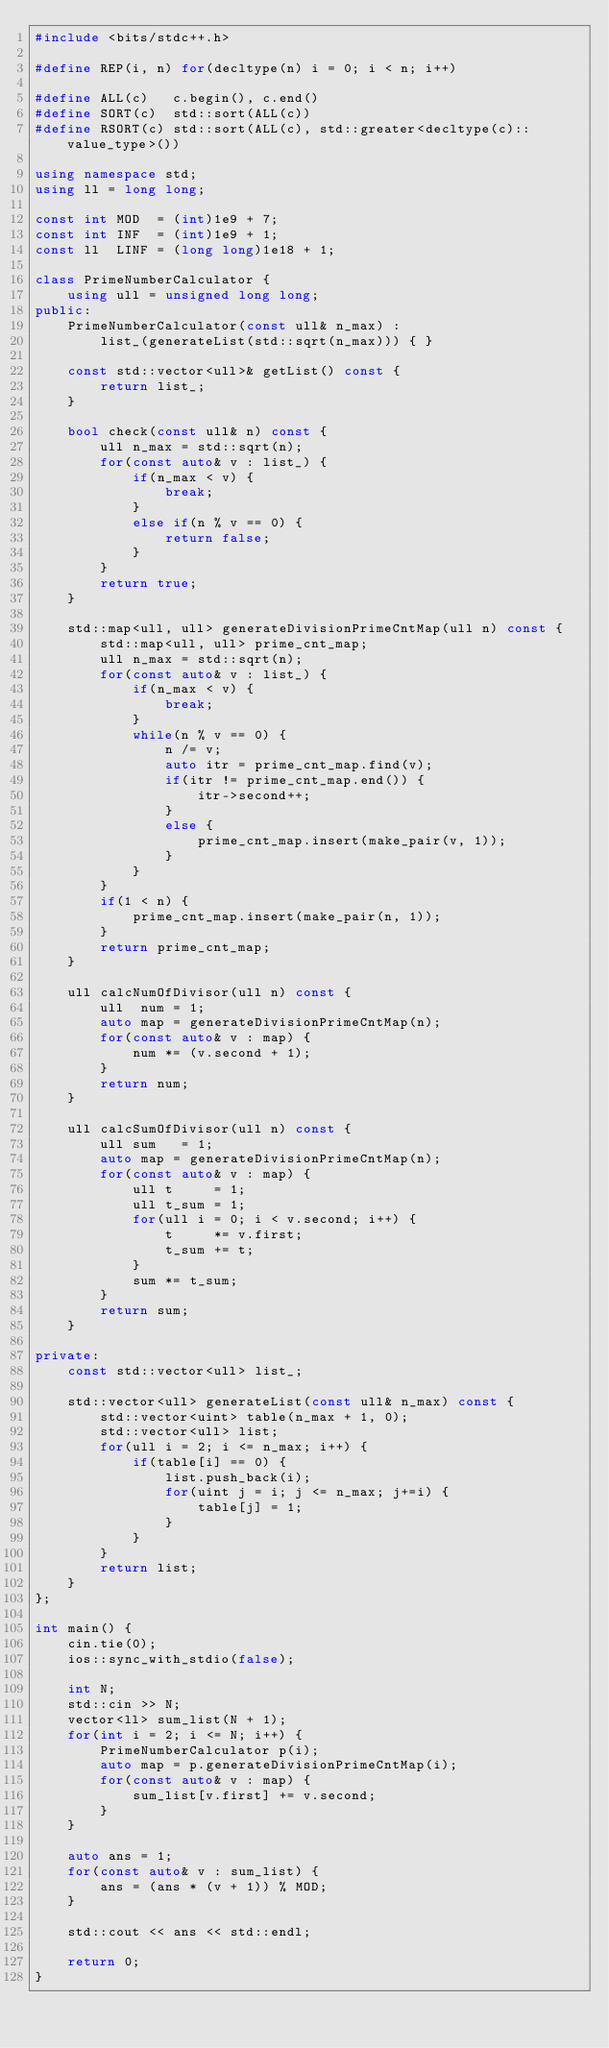<code> <loc_0><loc_0><loc_500><loc_500><_C++_>#include <bits/stdc++.h>

#define REP(i, n) for(decltype(n) i = 0; i < n; i++)

#define ALL(c)   c.begin(), c.end()
#define SORT(c)  std::sort(ALL(c))
#define RSORT(c) std::sort(ALL(c), std::greater<decltype(c)::value_type>())

using namespace std;
using ll = long long;

const int MOD  = (int)1e9 + 7;
const int INF  = (int)1e9 + 1;
const ll  LINF = (long long)1e18 + 1;

class PrimeNumberCalculator {
    using ull = unsigned long long;
public:
    PrimeNumberCalculator(const ull& n_max) :
        list_(generateList(std::sqrt(n_max))) { }

    const std::vector<ull>& getList() const {
        return list_;
    }

    bool check(const ull& n) const {
        ull n_max = std::sqrt(n);
        for(const auto& v : list_) {
            if(n_max < v) {
                break;
            }
            else if(n % v == 0) {
                return false;
            }
        }
        return true;
    }

    std::map<ull, ull> generateDivisionPrimeCntMap(ull n) const {
        std::map<ull, ull> prime_cnt_map;
        ull n_max = std::sqrt(n);
        for(const auto& v : list_) {
            if(n_max < v) {
                break;
            }
            while(n % v == 0) {
                n /= v;
                auto itr = prime_cnt_map.find(v);
                if(itr != prime_cnt_map.end()) {
                    itr->second++;
                }
                else {
                    prime_cnt_map.insert(make_pair(v, 1));
                }
            }
        }
        if(1 < n) {
            prime_cnt_map.insert(make_pair(n, 1));
        }
        return prime_cnt_map;
    }

    ull calcNumOfDivisor(ull n) const {
        ull  num = 1;
        auto map = generateDivisionPrimeCntMap(n);
        for(const auto& v : map) {
            num *= (v.second + 1);
        }
        return num;
    }

    ull calcSumOfDivisor(ull n) const {
        ull sum   = 1;
        auto map = generateDivisionPrimeCntMap(n);
        for(const auto& v : map) {
            ull t     = 1;
            ull t_sum = 1;
            for(ull i = 0; i < v.second; i++) {
                t     *= v.first;
                t_sum += t;
            }
            sum *= t_sum;
        }
        return sum;
    }

private:
    const std::vector<ull> list_;

    std::vector<ull> generateList(const ull& n_max) const {
        std::vector<uint> table(n_max + 1, 0);
        std::vector<ull> list;
        for(ull i = 2; i <= n_max; i++) {
            if(table[i] == 0) {
                list.push_back(i);
                for(uint j = i; j <= n_max; j+=i) {
                    table[j] = 1;
                }
            }
        }
        return list;
    }
};

int main() {
    cin.tie(0);
    ios::sync_with_stdio(false);

    int N;
    std::cin >> N;
    vector<ll> sum_list(N + 1);
    for(int i = 2; i <= N; i++) {
        PrimeNumberCalculator p(i);
        auto map = p.generateDivisionPrimeCntMap(i);
        for(const auto& v : map) {
            sum_list[v.first] += v.second;
        }
    }

    auto ans = 1;
    for(const auto& v : sum_list) {
        ans = (ans * (v + 1)) % MOD;
    }

    std::cout << ans << std::endl;

    return 0;
}
</code> 